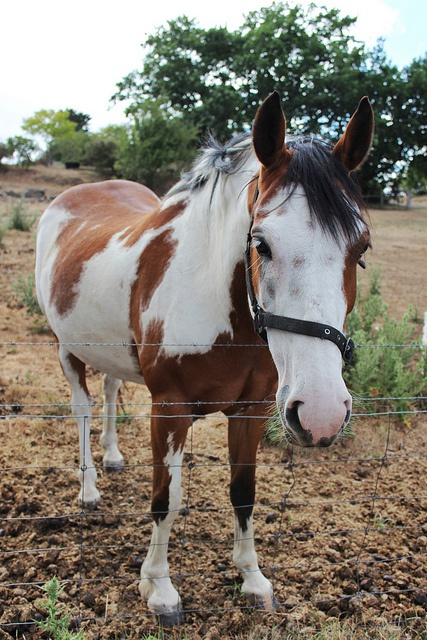Describe the objects in this image and their specific colors. I can see a horse in white, darkgray, black, lightgray, and maroon tones in this image. 